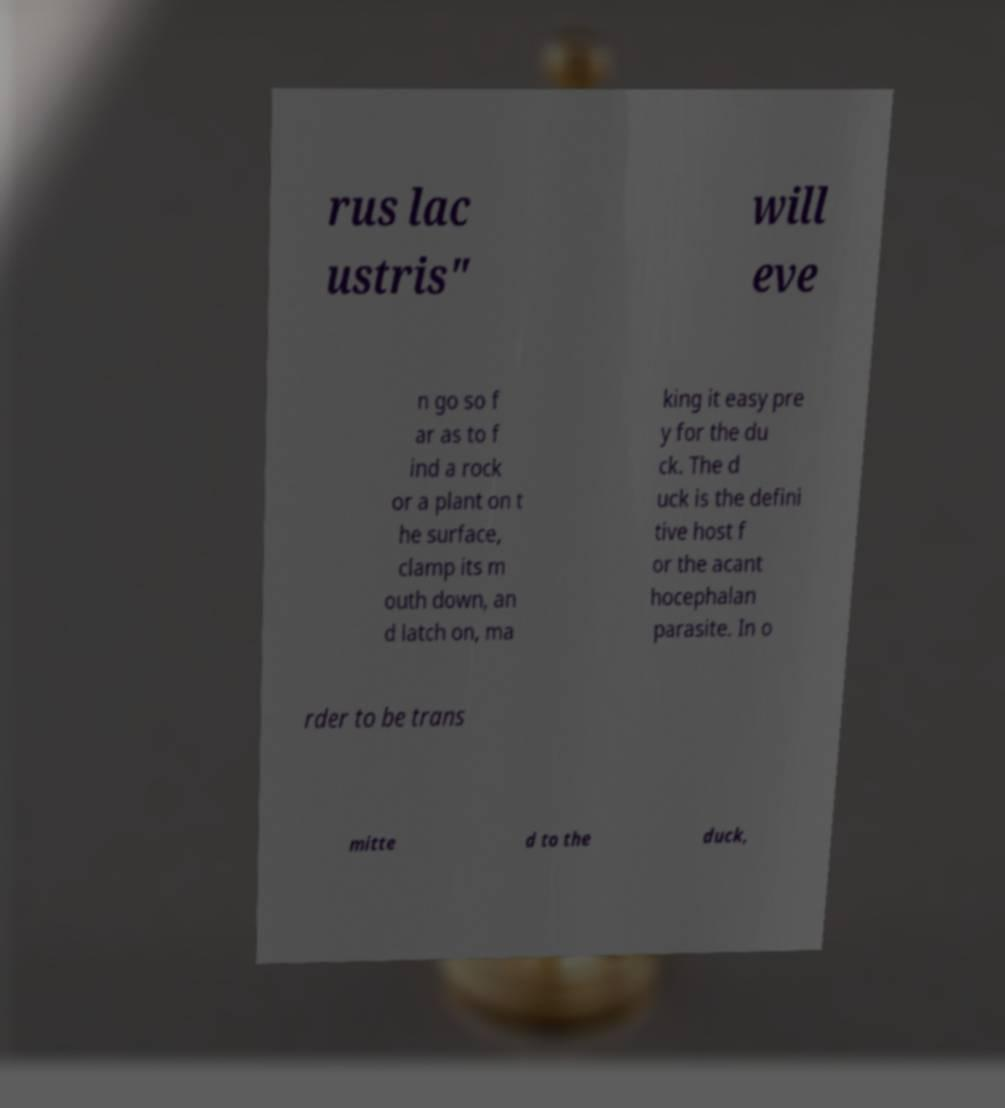Can you accurately transcribe the text from the provided image for me? rus lac ustris" will eve n go so f ar as to f ind a rock or a plant on t he surface, clamp its m outh down, an d latch on, ma king it easy pre y for the du ck. The d uck is the defini tive host f or the acant hocephalan parasite. In o rder to be trans mitte d to the duck, 